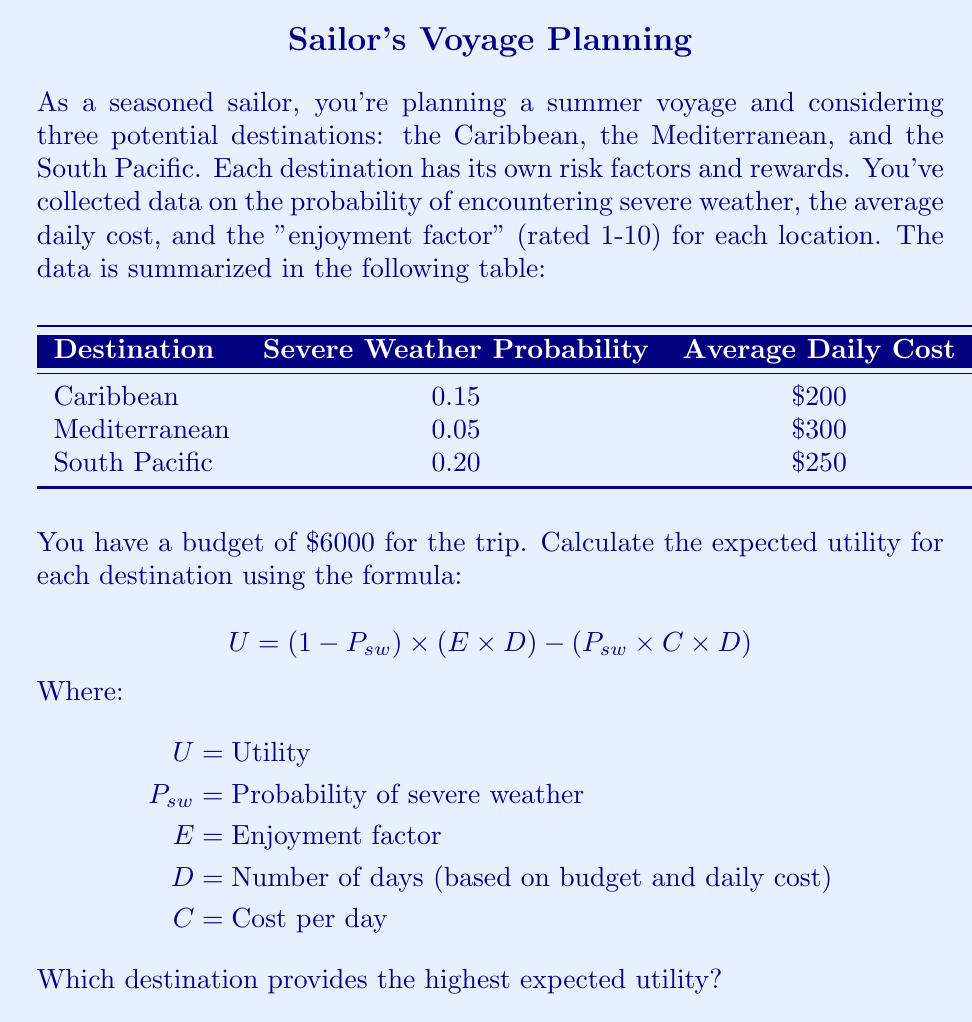Give your solution to this math problem. Let's calculate the utility for each destination step-by-step:

1. Calculate the number of days (D) for each destination:
   Caribbean: $D_C = 6000 / 200 = 30$ days
   Mediterranean: $D_M = 6000 / 300 = 20$ days
   South Pacific: $D_S = 6000 / 250 = 24$ days

2. Calculate the utility for each destination:

   Caribbean:
   $U_C = (1 - 0.15) \times (8 \times 30) - (0.15 \times 200 \times 30)$
   $U_C = 0.85 \times 240 - 900 = 204 - 900 = -696$

   Mediterranean:
   $U_M = (1 - 0.05) \times (9 \times 20) - (0.05 \times 300 \times 20)$
   $U_M = 0.95 \times 180 - 300 = 171 - 300 = -129$

   South Pacific:
   $U_S = (1 - 0.20) \times (10 \times 24) - (0.20 \times 250 \times 24)$
   $U_S = 0.80 \times 240 - 1200 = 192 - 1200 = -1008$

3. Compare the utilities:
   Caribbean: -696
   Mediterranean: -129
   South Pacific: -1008

The highest (least negative) utility is for the Mediterranean at -129.
Answer: Mediterranean 